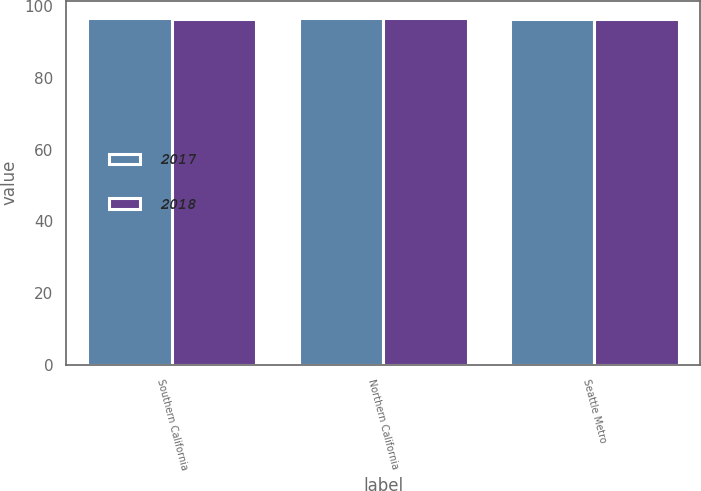Convert chart to OTSL. <chart><loc_0><loc_0><loc_500><loc_500><stacked_bar_chart><ecel><fcel>Southern California<fcel>Northern California<fcel>Seattle Metro<nl><fcel>2017<fcel>96.7<fcel>96.8<fcel>96.5<nl><fcel>2018<fcel>96.6<fcel>96.8<fcel>96.4<nl></chart> 